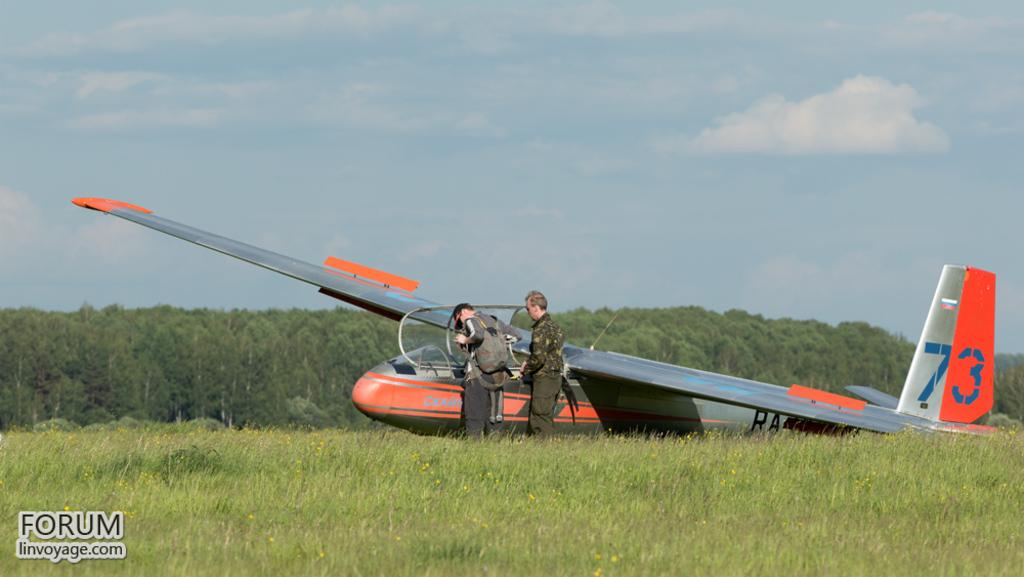<image>
Write a terse but informative summary of the picture. A plane numbered 73 sits on the ground with two people in front of it. 